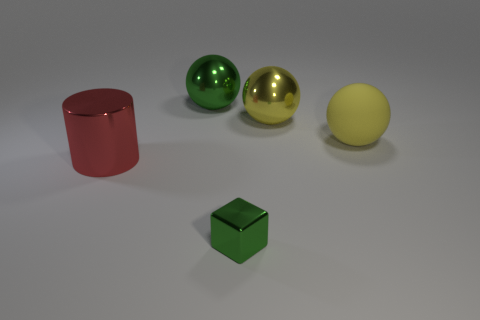There is a rubber ball; does it have the same color as the metal ball that is to the right of the tiny green metal object?
Your answer should be compact. Yes. How many blocks are in front of the green ball?
Your answer should be compact. 1. Are there fewer metallic cylinders that are on the right side of the large rubber object than purple metal blocks?
Provide a succinct answer. No. The small metal thing is what color?
Keep it short and to the point. Green. Is the color of the big metallic object in front of the yellow matte ball the same as the rubber object?
Provide a succinct answer. No. What color is the other large shiny thing that is the same shape as the large yellow metallic object?
Ensure brevity in your answer.  Green. How many big objects are yellow rubber cylinders or red objects?
Give a very brief answer. 1. There is a green shiny thing that is behind the small metal cube; what is its size?
Keep it short and to the point. Large. Are there any matte balls that have the same color as the cylinder?
Your answer should be very brief. No. Do the large rubber thing and the tiny block have the same color?
Ensure brevity in your answer.  No. 